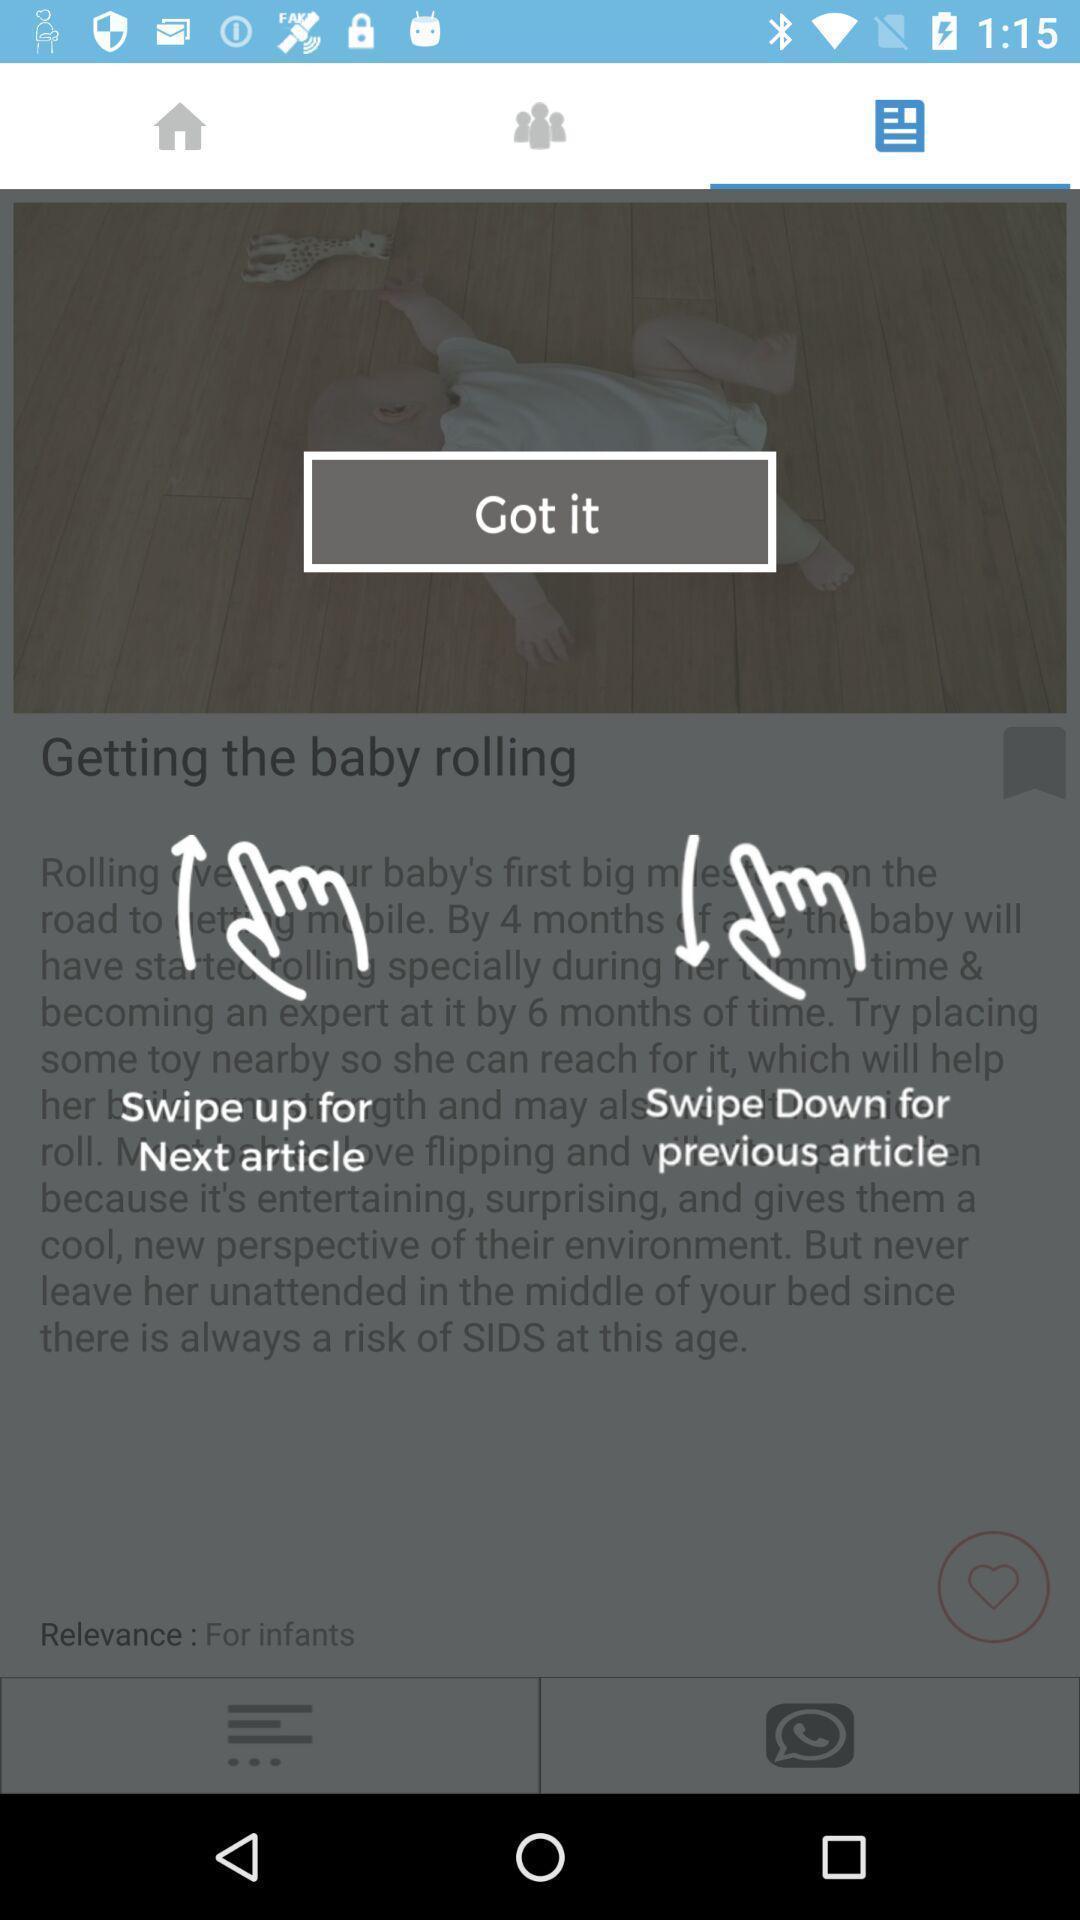What is the overall content of this screenshot? Page displays instructions in app. 